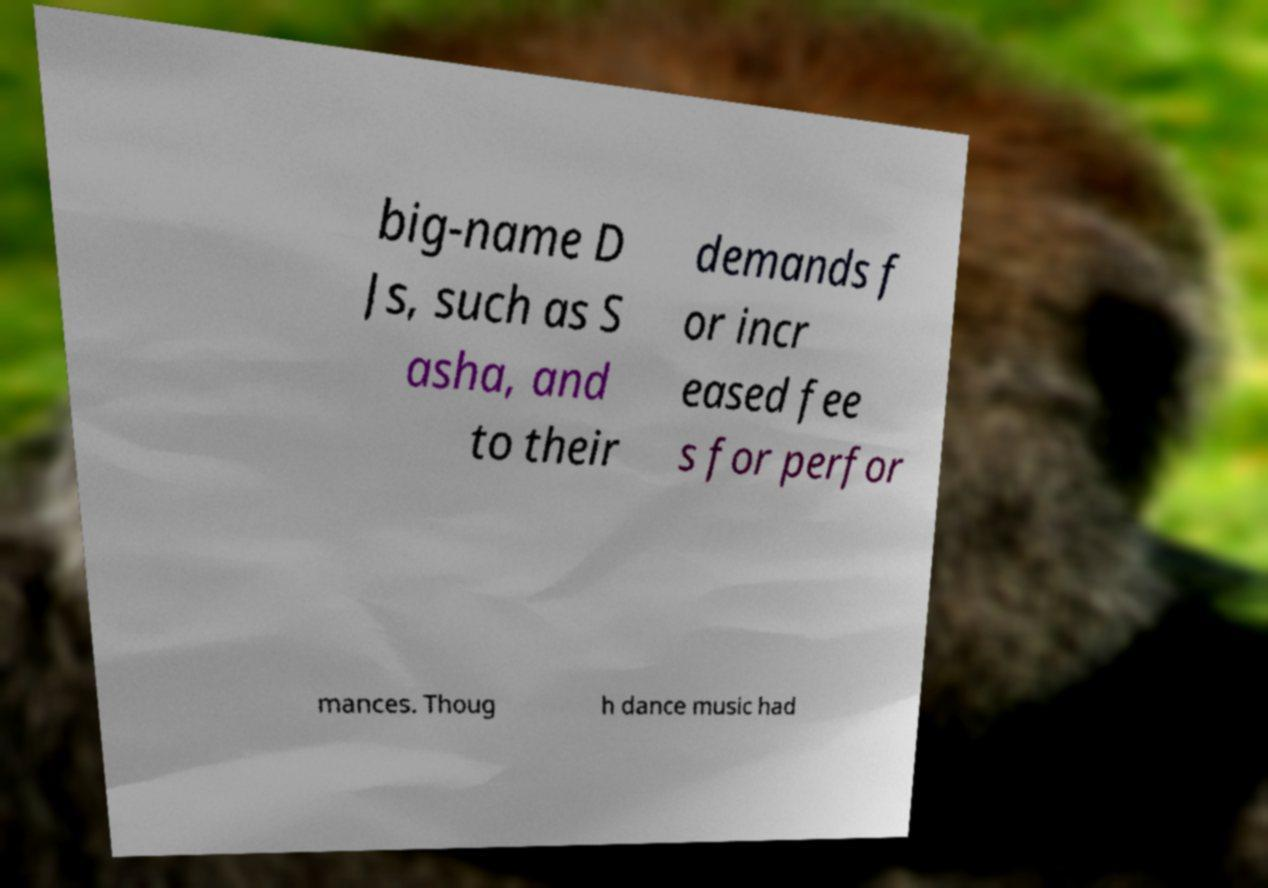Please read and relay the text visible in this image. What does it say? big-name D Js, such as S asha, and to their demands f or incr eased fee s for perfor mances. Thoug h dance music had 